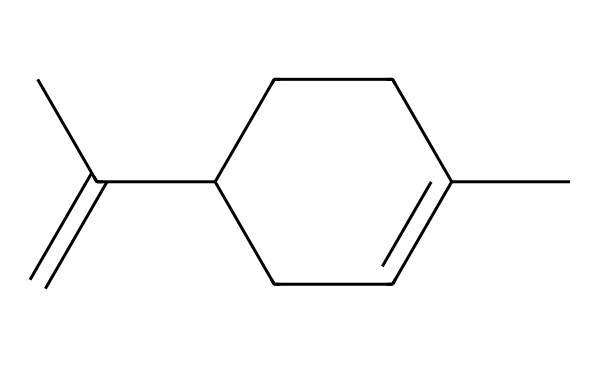What is the molecular formula of limonene? The structural formula shows six carbon atoms (C) and 10 hydrogen atoms (H). Therefore, the molecular formula can be derived as C6H10.
Answer: C6H10 How many rings are present in limonene? The structure of limonene contains one cyclohexane ring, evident from the cyclic part in the formula.
Answer: one What type of compound is limonene classified as? Limonene has single bonds in its structure and is an aliphatic hydrocarbon with a functional group indicating it is a terpene.
Answer: terpene What type of double bond configuration is found in limonene? The double bond present in limonene is a cis configuration, which is identified by the arrangement of hydrogens on the same side of the double bond.
Answer: cis How many double bonds are in limonene's structure? By examining the structure, it is clear that there is one double bond between certain carbon atoms, shown by the ‘=’ sign in the formula.
Answer: one What is the significance of the branch in limonene’s structure? The branched structure (from the propyl chain) contributes to the unique citrus scent of limonene, which is also associated with its effectiveness in insect repellent.
Answer: unique scent 